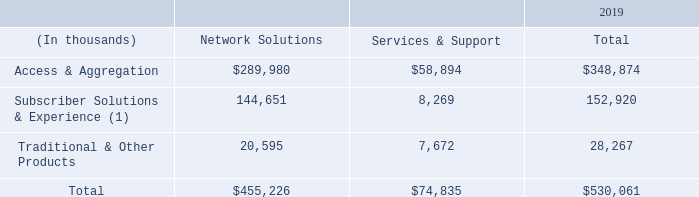Sales by Category
In addition to the above reporting segments, we also report revenue for the following three categories – (1) Access & Aggregation, (2) Subscriber Solutions & Experience and (3) Traditional & Other Products.
The following tables disaggregates our revenue by major source for the years ended December 31, 2019, 2018 and 2017:
(1) Subscriber Solutions & Experience was formerly reported as Customer Devices. With the increasing focus on enhancing the customer experience for both our business and consumer broadband customers and the addition of SmartRG during the fourth quarter of 2018, Subscriber Solutions & Experience more accurately represents this revenue category.
What was the total revenue from Access & Aggregation in 2019?
Answer scale should be: thousand. $348,874. What was Subscriber Solutions & Experience formerly reported as? Customer devices. What was the total revenue from Traditional & other Products?
Answer scale should be: thousand. 28,267. What is the difference in the total revenue from Access & Aggregation and Traditional & Other Products?
Answer scale should be: thousand. 348,874-28,267
Answer: 320607. How many categories did total revenue exceed $100,000 thousand? Access & Aggregation##Subscriber Solutions & Experience
Answer: 2. What is the total revenue from Network Solutions as a percentage of total revenue from all segments?
Answer scale should be: percent. 455,226/530,061
Answer: 85.88. 